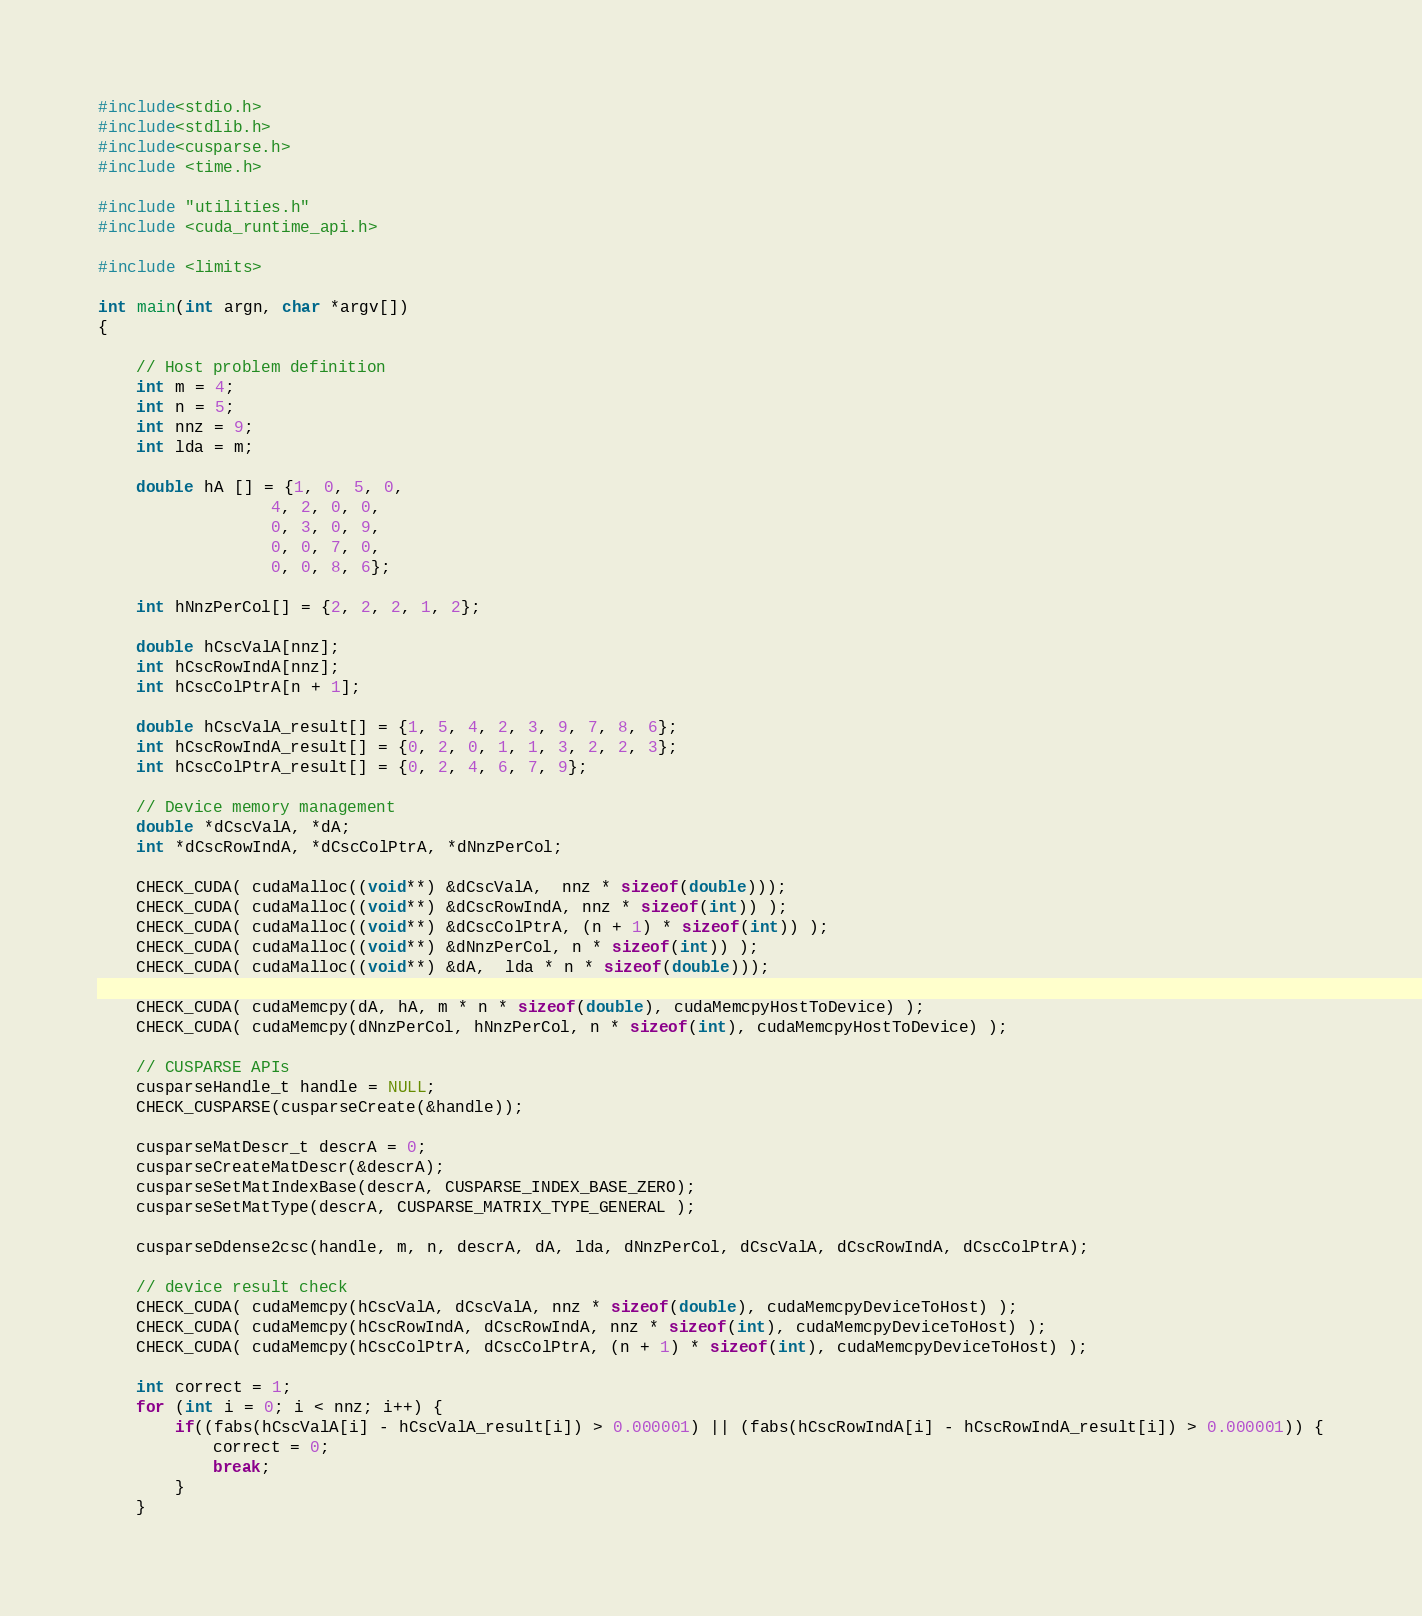<code> <loc_0><loc_0><loc_500><loc_500><_Cuda_>#include<stdio.h>
#include<stdlib.h>
#include<cusparse.h>
#include <time.h>

#include "utilities.h"
#include <cuda_runtime_api.h>

#include <limits>

int main(int argn, char *argv[])
{

    // Host problem definition
    int m = 4;
    int n = 5;
    int nnz = 9;
    int lda = m;

    double hA [] = {1, 0, 5, 0,
                  4, 2, 0, 0,
                  0, 3, 0, 9,
                  0, 0, 7, 0,
                  0, 0, 8, 6};

    int hNnzPerCol[] = {2, 2, 2, 1, 2};

    double hCscValA[nnz];
    int hCscRowIndA[nnz];
    int hCscColPtrA[n + 1];

    double hCscValA_result[] = {1, 5, 4, 2, 3, 9, 7, 8, 6};
    int hCscRowIndA_result[] = {0, 2, 0, 1, 1, 3, 2, 2, 3};
    int hCscColPtrA_result[] = {0, 2, 4, 6, 7, 9};

    // Device memory management
    double *dCscValA, *dA;
    int *dCscRowIndA, *dCscColPtrA, *dNnzPerCol;

    CHECK_CUDA( cudaMalloc((void**) &dCscValA,  nnz * sizeof(double)));
    CHECK_CUDA( cudaMalloc((void**) &dCscRowIndA, nnz * sizeof(int)) );
    CHECK_CUDA( cudaMalloc((void**) &dCscColPtrA, (n + 1) * sizeof(int)) );
    CHECK_CUDA( cudaMalloc((void**) &dNnzPerCol, n * sizeof(int)) );
    CHECK_CUDA( cudaMalloc((void**) &dA,  lda * n * sizeof(double)));

    CHECK_CUDA( cudaMemcpy(dA, hA, m * n * sizeof(double), cudaMemcpyHostToDevice) );
    CHECK_CUDA( cudaMemcpy(dNnzPerCol, hNnzPerCol, n * sizeof(int), cudaMemcpyHostToDevice) );

    // CUSPARSE APIs
    cusparseHandle_t handle = NULL;
    CHECK_CUSPARSE(cusparseCreate(&handle));

    cusparseMatDescr_t descrA = 0;
    cusparseCreateMatDescr(&descrA);
    cusparseSetMatIndexBase(descrA, CUSPARSE_INDEX_BASE_ZERO);
    cusparseSetMatType(descrA, CUSPARSE_MATRIX_TYPE_GENERAL );

    cusparseDdense2csc(handle, m, n, descrA, dA, lda, dNnzPerCol, dCscValA, dCscRowIndA, dCscColPtrA);

    // device result check
    CHECK_CUDA( cudaMemcpy(hCscValA, dCscValA, nnz * sizeof(double), cudaMemcpyDeviceToHost) );
    CHECK_CUDA( cudaMemcpy(hCscRowIndA, dCscRowIndA, nnz * sizeof(int), cudaMemcpyDeviceToHost) );
    CHECK_CUDA( cudaMemcpy(hCscColPtrA, dCscColPtrA, (n + 1) * sizeof(int), cudaMemcpyDeviceToHost) );

    int correct = 1;
    for (int i = 0; i < nnz; i++) {
        if((fabs(hCscValA[i] - hCscValA_result[i]) > 0.000001) || (fabs(hCscRowIndA[i] - hCscRowIndA_result[i]) > 0.000001)) {
            correct = 0;
            break;
        }
    }</code> 